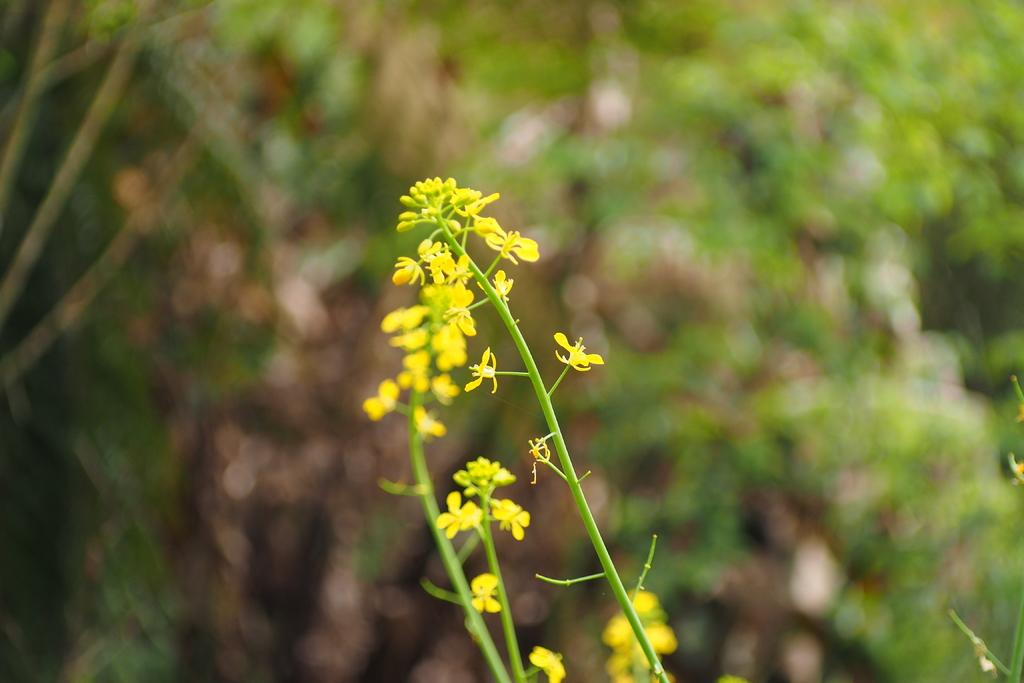What is located in the front of the image? There are flowers in the front of the image. Can you describe the background of the image? The background of the image is blurry. What discovery was made by the coach in the image? There is no coach or discovery present in the image. The image only features flowers in the front and a blurry background. 